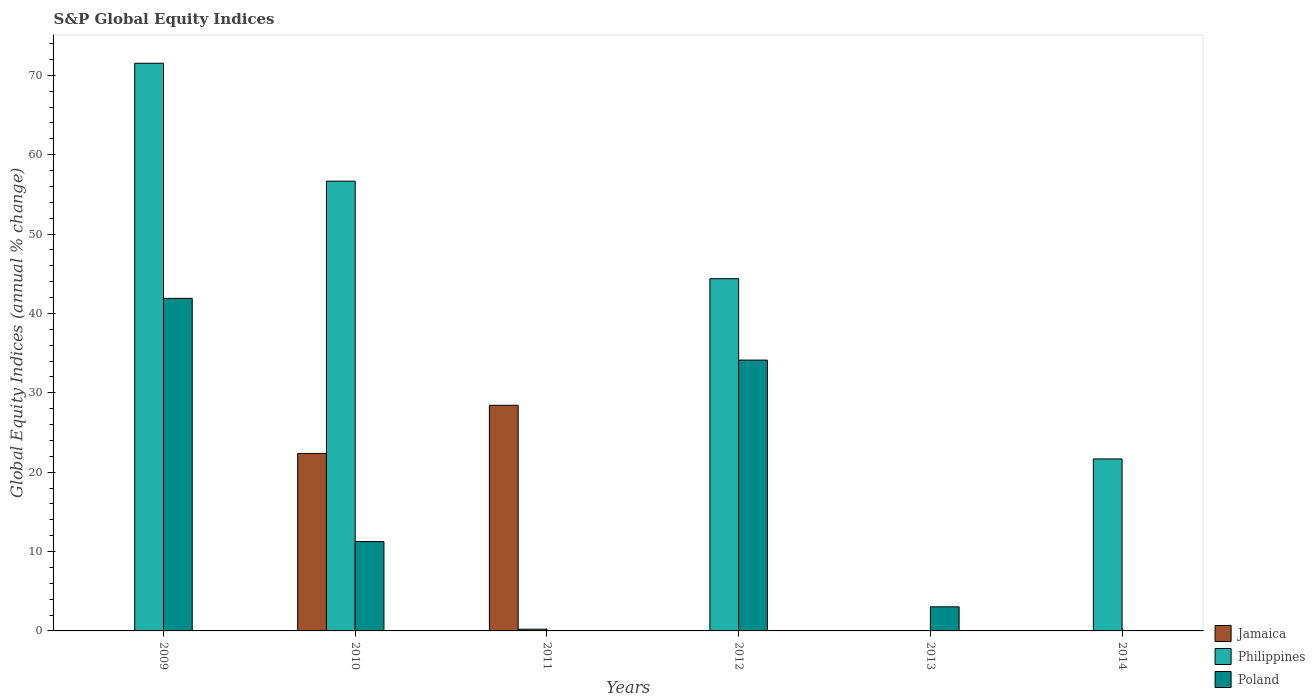How many bars are there on the 5th tick from the right?
Your answer should be compact. 3. Across all years, what is the maximum global equity indices in Poland?
Provide a short and direct response. 41.9. Across all years, what is the minimum global equity indices in Jamaica?
Your answer should be compact. 0. In which year was the global equity indices in Jamaica maximum?
Keep it short and to the point. 2011. What is the total global equity indices in Jamaica in the graph?
Your answer should be very brief. 50.79. What is the difference between the global equity indices in Poland in 2009 and that in 2010?
Offer a very short reply. 30.64. What is the difference between the global equity indices in Philippines in 2011 and the global equity indices in Jamaica in 2009?
Provide a short and direct response. 0.22. What is the average global equity indices in Philippines per year?
Ensure brevity in your answer.  32.41. In the year 2009, what is the difference between the global equity indices in Poland and global equity indices in Philippines?
Offer a very short reply. -29.62. In how many years, is the global equity indices in Philippines greater than 8 %?
Your response must be concise. 4. What is the ratio of the global equity indices in Philippines in 2012 to that in 2014?
Provide a succinct answer. 2.05. Is the global equity indices in Poland in 2009 less than that in 2013?
Give a very brief answer. No. What is the difference between the highest and the second highest global equity indices in Poland?
Ensure brevity in your answer.  7.78. What is the difference between the highest and the lowest global equity indices in Jamaica?
Your response must be concise. 28.43. In how many years, is the global equity indices in Poland greater than the average global equity indices in Poland taken over all years?
Your answer should be compact. 2. Is it the case that in every year, the sum of the global equity indices in Poland and global equity indices in Philippines is greater than the global equity indices in Jamaica?
Make the answer very short. No. What is the difference between two consecutive major ticks on the Y-axis?
Provide a succinct answer. 10. Are the values on the major ticks of Y-axis written in scientific E-notation?
Your answer should be compact. No. Does the graph contain any zero values?
Make the answer very short. Yes. Does the graph contain grids?
Give a very brief answer. No. Where does the legend appear in the graph?
Provide a short and direct response. Bottom right. How many legend labels are there?
Provide a short and direct response. 3. What is the title of the graph?
Give a very brief answer. S&P Global Equity Indices. Does "Aruba" appear as one of the legend labels in the graph?
Give a very brief answer. No. What is the label or title of the X-axis?
Provide a succinct answer. Years. What is the label or title of the Y-axis?
Offer a terse response. Global Equity Indices (annual % change). What is the Global Equity Indices (annual % change) of Philippines in 2009?
Provide a succinct answer. 71.52. What is the Global Equity Indices (annual % change) of Poland in 2009?
Give a very brief answer. 41.9. What is the Global Equity Indices (annual % change) in Jamaica in 2010?
Your answer should be very brief. 22.36. What is the Global Equity Indices (annual % change) of Philippines in 2010?
Keep it short and to the point. 56.67. What is the Global Equity Indices (annual % change) in Poland in 2010?
Offer a terse response. 11.26. What is the Global Equity Indices (annual % change) in Jamaica in 2011?
Offer a terse response. 28.43. What is the Global Equity Indices (annual % change) in Philippines in 2011?
Offer a terse response. 0.22. What is the Global Equity Indices (annual % change) of Philippines in 2012?
Keep it short and to the point. 44.38. What is the Global Equity Indices (annual % change) in Poland in 2012?
Your answer should be compact. 34.12. What is the Global Equity Indices (annual % change) in Jamaica in 2013?
Your answer should be compact. 0. What is the Global Equity Indices (annual % change) of Philippines in 2013?
Your response must be concise. 0. What is the Global Equity Indices (annual % change) in Poland in 2013?
Ensure brevity in your answer.  3.04. What is the Global Equity Indices (annual % change) of Jamaica in 2014?
Give a very brief answer. 0. What is the Global Equity Indices (annual % change) in Philippines in 2014?
Provide a short and direct response. 21.67. Across all years, what is the maximum Global Equity Indices (annual % change) of Jamaica?
Give a very brief answer. 28.43. Across all years, what is the maximum Global Equity Indices (annual % change) of Philippines?
Your response must be concise. 71.52. Across all years, what is the maximum Global Equity Indices (annual % change) in Poland?
Give a very brief answer. 41.9. Across all years, what is the minimum Global Equity Indices (annual % change) in Jamaica?
Give a very brief answer. 0. Across all years, what is the minimum Global Equity Indices (annual % change) of Philippines?
Your response must be concise. 0. What is the total Global Equity Indices (annual % change) in Jamaica in the graph?
Your answer should be very brief. 50.79. What is the total Global Equity Indices (annual % change) of Philippines in the graph?
Provide a succinct answer. 194.45. What is the total Global Equity Indices (annual % change) in Poland in the graph?
Offer a terse response. 90.32. What is the difference between the Global Equity Indices (annual % change) in Philippines in 2009 and that in 2010?
Your answer should be compact. 14.85. What is the difference between the Global Equity Indices (annual % change) of Poland in 2009 and that in 2010?
Provide a succinct answer. 30.64. What is the difference between the Global Equity Indices (annual % change) in Philippines in 2009 and that in 2011?
Give a very brief answer. 71.31. What is the difference between the Global Equity Indices (annual % change) of Philippines in 2009 and that in 2012?
Keep it short and to the point. 27.14. What is the difference between the Global Equity Indices (annual % change) of Poland in 2009 and that in 2012?
Keep it short and to the point. 7.78. What is the difference between the Global Equity Indices (annual % change) in Poland in 2009 and that in 2013?
Provide a succinct answer. 38.86. What is the difference between the Global Equity Indices (annual % change) in Philippines in 2009 and that in 2014?
Offer a terse response. 49.85. What is the difference between the Global Equity Indices (annual % change) in Jamaica in 2010 and that in 2011?
Your response must be concise. -6.07. What is the difference between the Global Equity Indices (annual % change) in Philippines in 2010 and that in 2011?
Your answer should be very brief. 56.45. What is the difference between the Global Equity Indices (annual % change) in Philippines in 2010 and that in 2012?
Your answer should be compact. 12.29. What is the difference between the Global Equity Indices (annual % change) of Poland in 2010 and that in 2012?
Give a very brief answer. -22.86. What is the difference between the Global Equity Indices (annual % change) in Poland in 2010 and that in 2013?
Make the answer very short. 8.22. What is the difference between the Global Equity Indices (annual % change) of Philippines in 2010 and that in 2014?
Provide a short and direct response. 35. What is the difference between the Global Equity Indices (annual % change) in Philippines in 2011 and that in 2012?
Make the answer very short. -44.16. What is the difference between the Global Equity Indices (annual % change) of Philippines in 2011 and that in 2014?
Make the answer very short. -21.45. What is the difference between the Global Equity Indices (annual % change) in Poland in 2012 and that in 2013?
Offer a terse response. 31.09. What is the difference between the Global Equity Indices (annual % change) of Philippines in 2012 and that in 2014?
Your answer should be very brief. 22.71. What is the difference between the Global Equity Indices (annual % change) of Philippines in 2009 and the Global Equity Indices (annual % change) of Poland in 2010?
Offer a terse response. 60.26. What is the difference between the Global Equity Indices (annual % change) in Philippines in 2009 and the Global Equity Indices (annual % change) in Poland in 2012?
Provide a short and direct response. 37.4. What is the difference between the Global Equity Indices (annual % change) in Philippines in 2009 and the Global Equity Indices (annual % change) in Poland in 2013?
Your response must be concise. 68.49. What is the difference between the Global Equity Indices (annual % change) of Jamaica in 2010 and the Global Equity Indices (annual % change) of Philippines in 2011?
Provide a short and direct response. 22.15. What is the difference between the Global Equity Indices (annual % change) in Jamaica in 2010 and the Global Equity Indices (annual % change) in Philippines in 2012?
Your answer should be compact. -22.02. What is the difference between the Global Equity Indices (annual % change) in Jamaica in 2010 and the Global Equity Indices (annual % change) in Poland in 2012?
Offer a terse response. -11.76. What is the difference between the Global Equity Indices (annual % change) of Philippines in 2010 and the Global Equity Indices (annual % change) of Poland in 2012?
Provide a short and direct response. 22.55. What is the difference between the Global Equity Indices (annual % change) of Jamaica in 2010 and the Global Equity Indices (annual % change) of Poland in 2013?
Give a very brief answer. 19.33. What is the difference between the Global Equity Indices (annual % change) in Philippines in 2010 and the Global Equity Indices (annual % change) in Poland in 2013?
Provide a short and direct response. 53.63. What is the difference between the Global Equity Indices (annual % change) in Jamaica in 2010 and the Global Equity Indices (annual % change) in Philippines in 2014?
Provide a succinct answer. 0.69. What is the difference between the Global Equity Indices (annual % change) of Jamaica in 2011 and the Global Equity Indices (annual % change) of Philippines in 2012?
Offer a terse response. -15.95. What is the difference between the Global Equity Indices (annual % change) of Jamaica in 2011 and the Global Equity Indices (annual % change) of Poland in 2012?
Offer a very short reply. -5.69. What is the difference between the Global Equity Indices (annual % change) in Philippines in 2011 and the Global Equity Indices (annual % change) in Poland in 2012?
Your answer should be compact. -33.91. What is the difference between the Global Equity Indices (annual % change) in Jamaica in 2011 and the Global Equity Indices (annual % change) in Poland in 2013?
Provide a succinct answer. 25.39. What is the difference between the Global Equity Indices (annual % change) in Philippines in 2011 and the Global Equity Indices (annual % change) in Poland in 2013?
Make the answer very short. -2.82. What is the difference between the Global Equity Indices (annual % change) of Jamaica in 2011 and the Global Equity Indices (annual % change) of Philippines in 2014?
Keep it short and to the point. 6.76. What is the difference between the Global Equity Indices (annual % change) in Philippines in 2012 and the Global Equity Indices (annual % change) in Poland in 2013?
Offer a very short reply. 41.34. What is the average Global Equity Indices (annual % change) of Jamaica per year?
Your answer should be compact. 8.46. What is the average Global Equity Indices (annual % change) of Philippines per year?
Your answer should be compact. 32.41. What is the average Global Equity Indices (annual % change) of Poland per year?
Your answer should be compact. 15.05. In the year 2009, what is the difference between the Global Equity Indices (annual % change) of Philippines and Global Equity Indices (annual % change) of Poland?
Provide a succinct answer. 29.62. In the year 2010, what is the difference between the Global Equity Indices (annual % change) of Jamaica and Global Equity Indices (annual % change) of Philippines?
Provide a short and direct response. -34.31. In the year 2010, what is the difference between the Global Equity Indices (annual % change) of Jamaica and Global Equity Indices (annual % change) of Poland?
Provide a succinct answer. 11.1. In the year 2010, what is the difference between the Global Equity Indices (annual % change) of Philippines and Global Equity Indices (annual % change) of Poland?
Offer a very short reply. 45.41. In the year 2011, what is the difference between the Global Equity Indices (annual % change) in Jamaica and Global Equity Indices (annual % change) in Philippines?
Your answer should be very brief. 28.21. In the year 2012, what is the difference between the Global Equity Indices (annual % change) in Philippines and Global Equity Indices (annual % change) in Poland?
Your response must be concise. 10.25. What is the ratio of the Global Equity Indices (annual % change) of Philippines in 2009 to that in 2010?
Provide a succinct answer. 1.26. What is the ratio of the Global Equity Indices (annual % change) in Poland in 2009 to that in 2010?
Make the answer very short. 3.72. What is the ratio of the Global Equity Indices (annual % change) of Philippines in 2009 to that in 2011?
Give a very brief answer. 332.53. What is the ratio of the Global Equity Indices (annual % change) of Philippines in 2009 to that in 2012?
Offer a very short reply. 1.61. What is the ratio of the Global Equity Indices (annual % change) of Poland in 2009 to that in 2012?
Provide a succinct answer. 1.23. What is the ratio of the Global Equity Indices (annual % change) in Poland in 2009 to that in 2013?
Provide a short and direct response. 13.8. What is the ratio of the Global Equity Indices (annual % change) of Philippines in 2009 to that in 2014?
Offer a terse response. 3.3. What is the ratio of the Global Equity Indices (annual % change) in Jamaica in 2010 to that in 2011?
Make the answer very short. 0.79. What is the ratio of the Global Equity Indices (annual % change) in Philippines in 2010 to that in 2011?
Your answer should be very brief. 263.48. What is the ratio of the Global Equity Indices (annual % change) of Philippines in 2010 to that in 2012?
Your answer should be very brief. 1.28. What is the ratio of the Global Equity Indices (annual % change) of Poland in 2010 to that in 2012?
Your answer should be compact. 0.33. What is the ratio of the Global Equity Indices (annual % change) of Poland in 2010 to that in 2013?
Offer a very short reply. 3.71. What is the ratio of the Global Equity Indices (annual % change) in Philippines in 2010 to that in 2014?
Give a very brief answer. 2.62. What is the ratio of the Global Equity Indices (annual % change) in Philippines in 2011 to that in 2012?
Provide a short and direct response. 0. What is the ratio of the Global Equity Indices (annual % change) of Philippines in 2011 to that in 2014?
Offer a very short reply. 0.01. What is the ratio of the Global Equity Indices (annual % change) of Poland in 2012 to that in 2013?
Give a very brief answer. 11.24. What is the ratio of the Global Equity Indices (annual % change) of Philippines in 2012 to that in 2014?
Offer a very short reply. 2.05. What is the difference between the highest and the second highest Global Equity Indices (annual % change) in Philippines?
Make the answer very short. 14.85. What is the difference between the highest and the second highest Global Equity Indices (annual % change) of Poland?
Provide a succinct answer. 7.78. What is the difference between the highest and the lowest Global Equity Indices (annual % change) in Jamaica?
Your response must be concise. 28.43. What is the difference between the highest and the lowest Global Equity Indices (annual % change) in Philippines?
Offer a terse response. 71.52. What is the difference between the highest and the lowest Global Equity Indices (annual % change) in Poland?
Your answer should be compact. 41.9. 